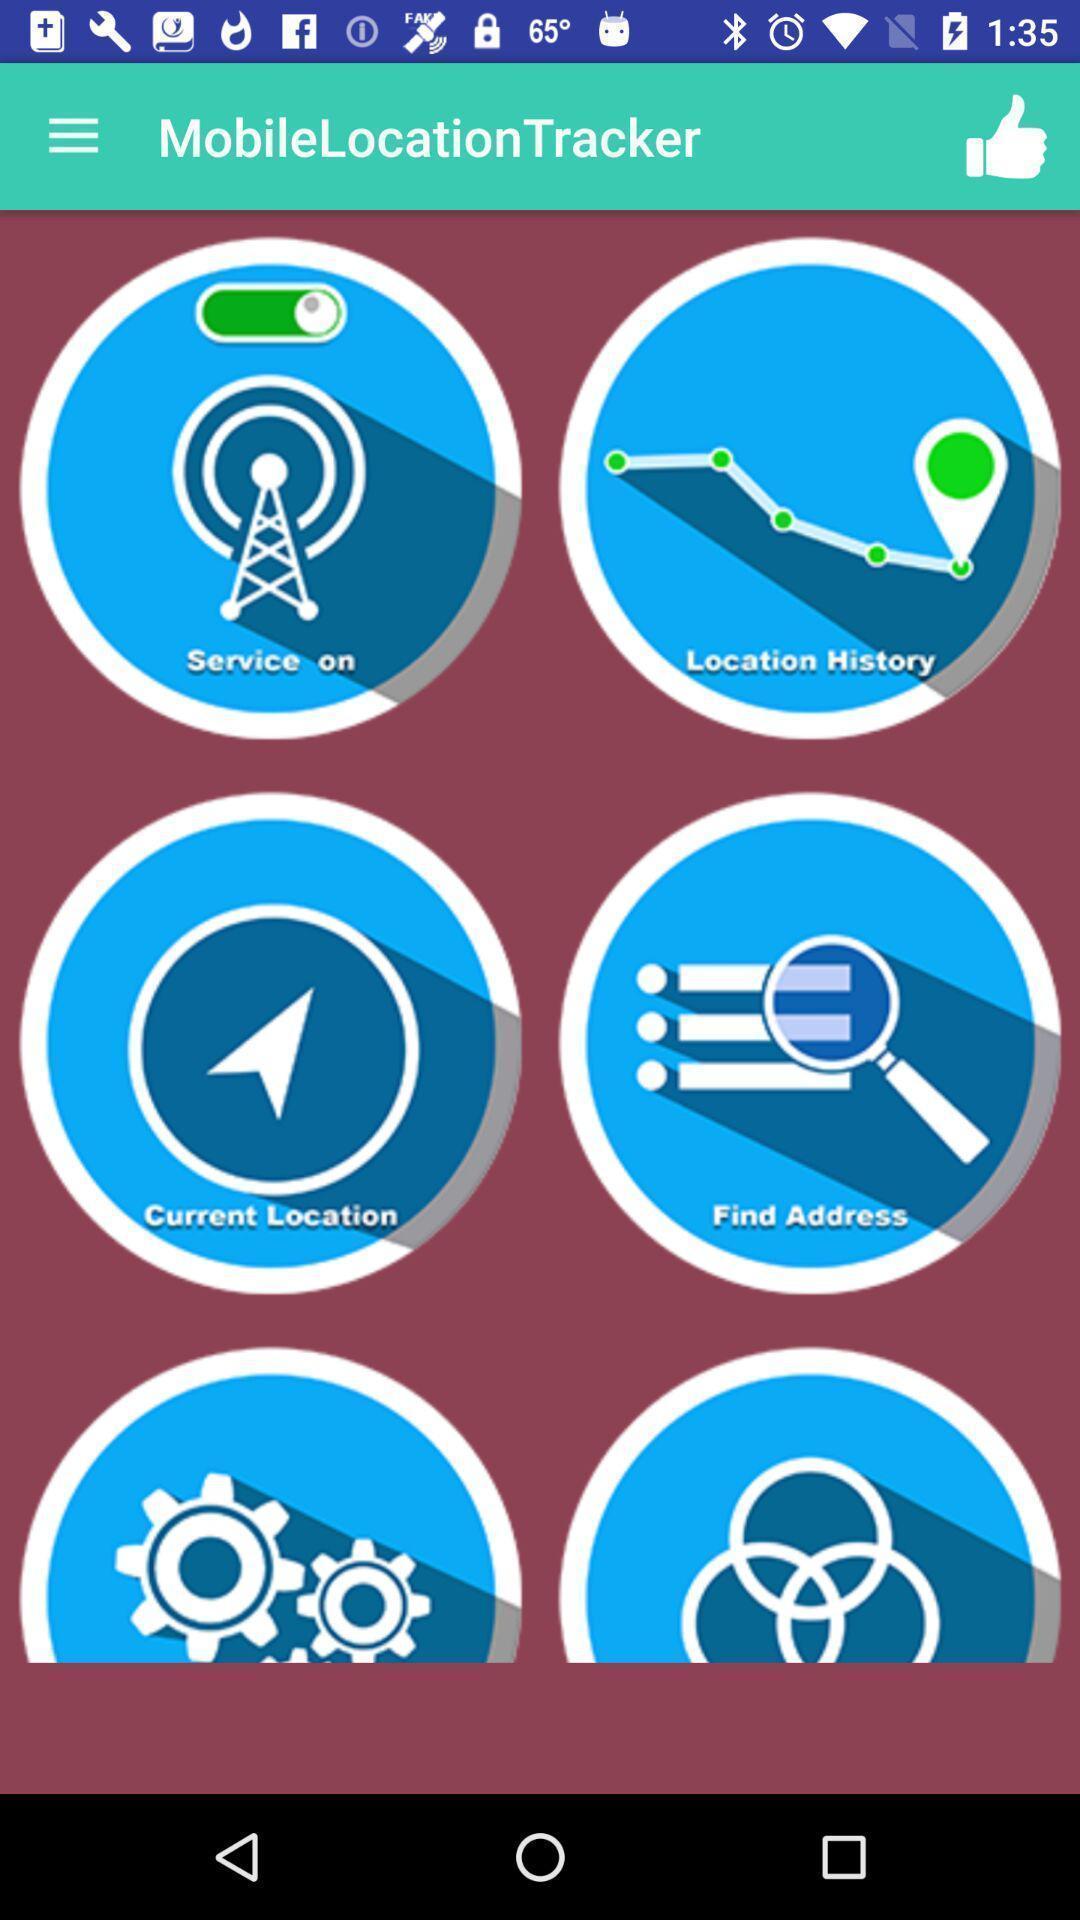Explain the elements present in this screenshot. Page showing different options on a navigational app. 